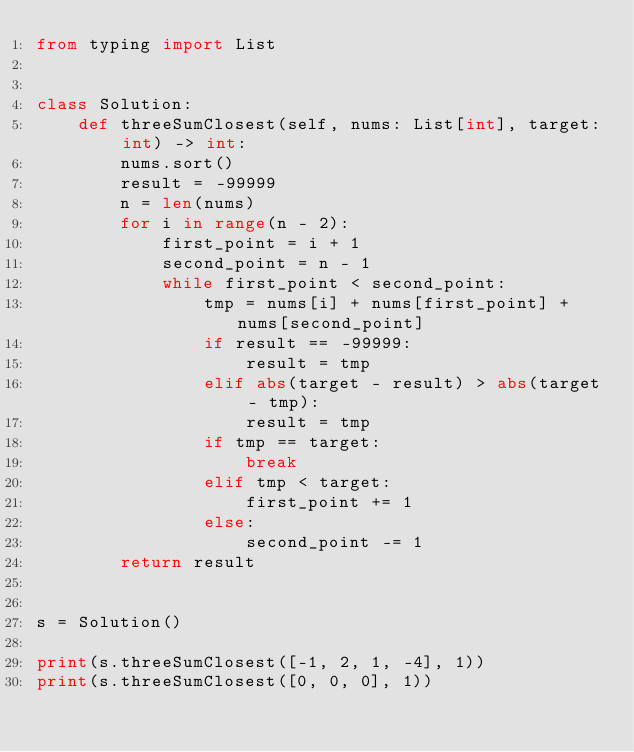Convert code to text. <code><loc_0><loc_0><loc_500><loc_500><_Python_>from typing import List


class Solution:
    def threeSumClosest(self, nums: List[int], target: int) -> int:
        nums.sort()
        result = -99999
        n = len(nums)
        for i in range(n - 2):
            first_point = i + 1
            second_point = n - 1
            while first_point < second_point:
                tmp = nums[i] + nums[first_point] + nums[second_point]
                if result == -99999:
                    result = tmp
                elif abs(target - result) > abs(target - tmp):
                    result = tmp
                if tmp == target:
                    break
                elif tmp < target:
                    first_point += 1
                else:
                    second_point -= 1
        return result


s = Solution()

print(s.threeSumClosest([-1, 2, 1, -4], 1))
print(s.threeSumClosest([0, 0, 0], 1))
</code> 